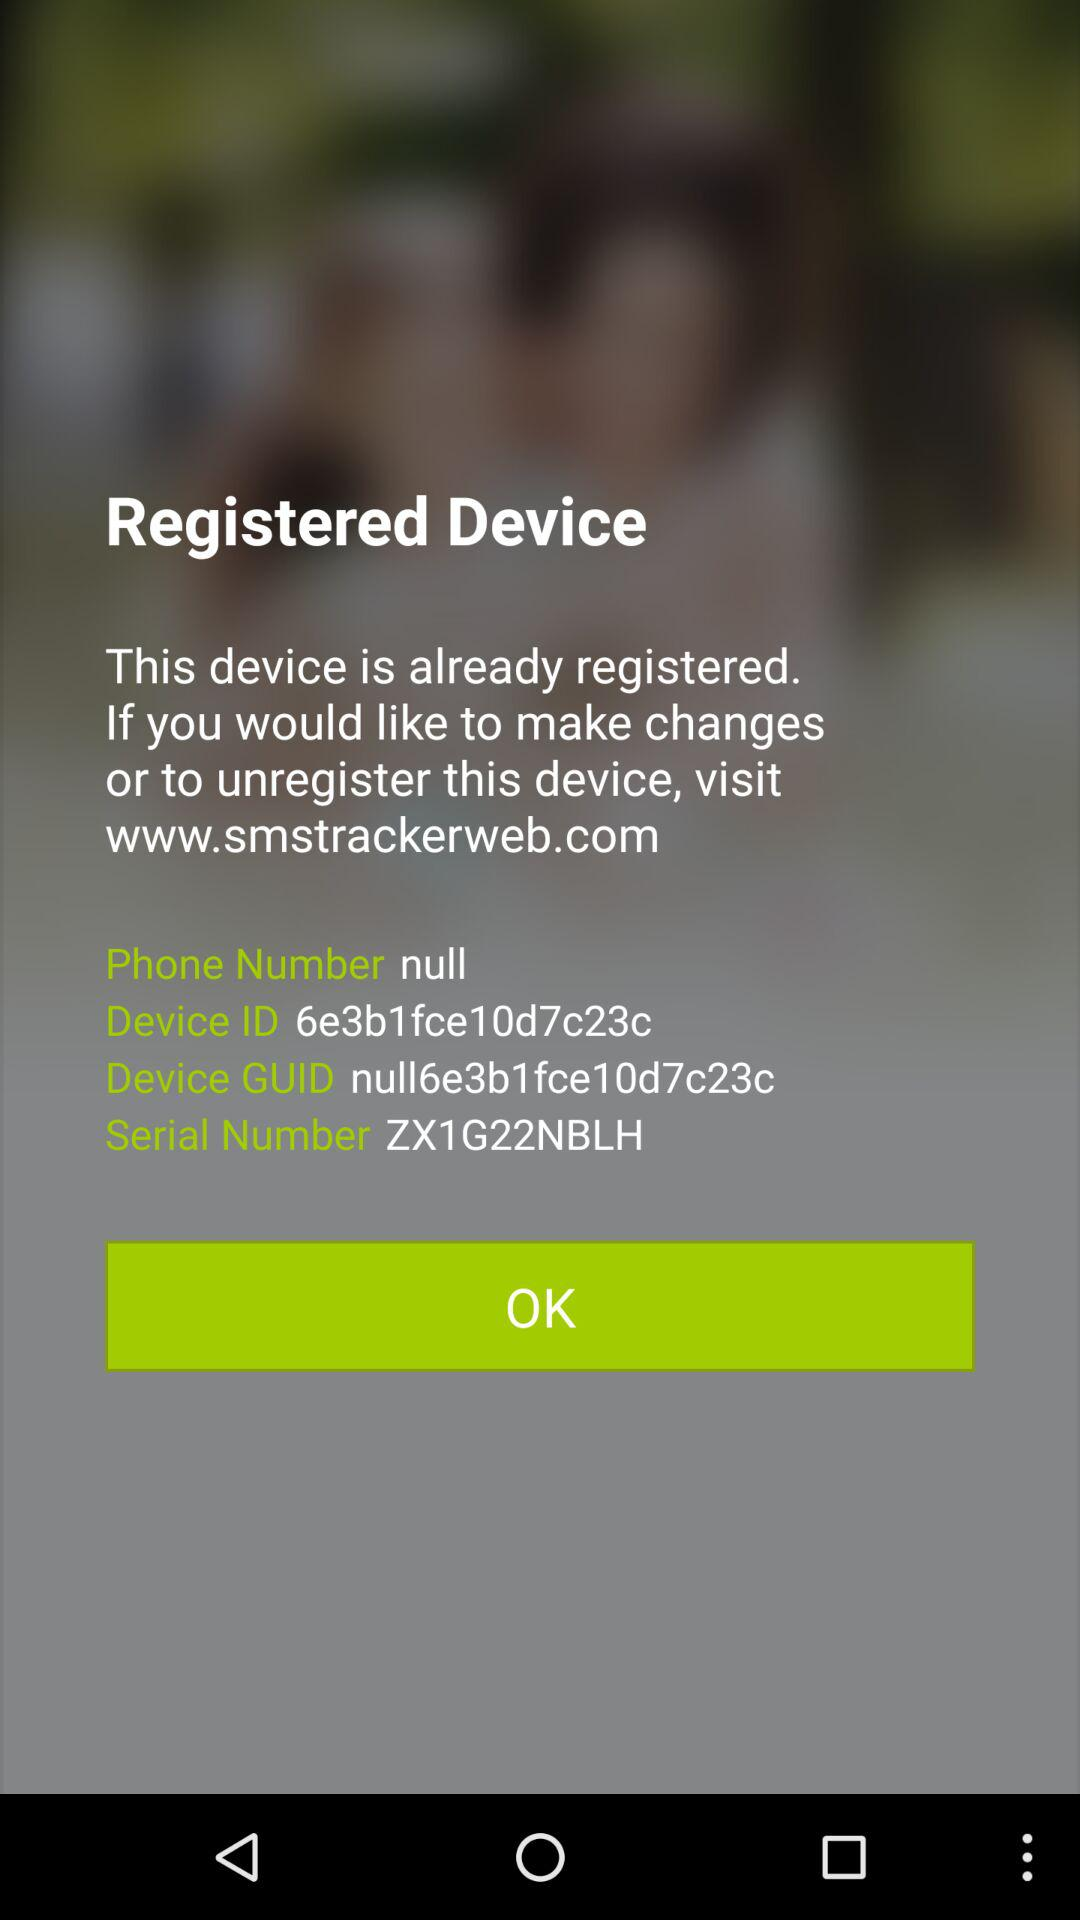What is the status of the "I agree with the policy stated above."? The status is "on". 